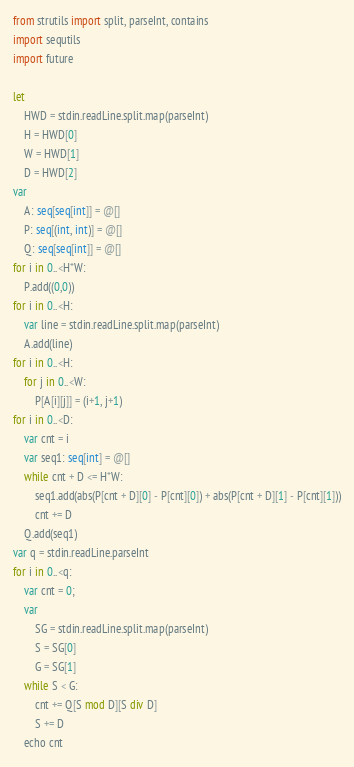<code> <loc_0><loc_0><loc_500><loc_500><_Nim_>from strutils import split, parseInt, contains 
import sequtils
import future

let
    HWD = stdin.readLine.split.map(parseInt)
    H = HWD[0]
    W = HWD[1]
    D = HWD[2]
var
    A: seq[seq[int]] = @[]
    P: seq[(int, int)] = @[]
    Q: seq[seq[int]] = @[]
for i in 0..<H*W:
    P.add((0,0))
for i in 0..<H:
    var line = stdin.readLine.split.map(parseInt)
    A.add(line)
for i in 0..<H:
    for j in 0..<W:
        P[A[i][j]] = (i+1, j+1)
for i in 0..<D:
    var cnt = i
    var seq1: seq[int] = @[]
    while cnt + D <= H*W:
        seq1.add(abs(P[cnt + D][0] - P[cnt][0]) + abs(P[cnt + D][1] - P[cnt][1]))
        cnt += D
    Q.add(seq1)
var q = stdin.readLine.parseInt
for i in 0..<q:
    var cnt = 0;
    var
        SG = stdin.readLine.split.map(parseInt)
        S = SG[0]
        G = SG[1]
    while S < G:
        cnt += Q[S mod D][S div D]
        S += D
    echo cnt</code> 